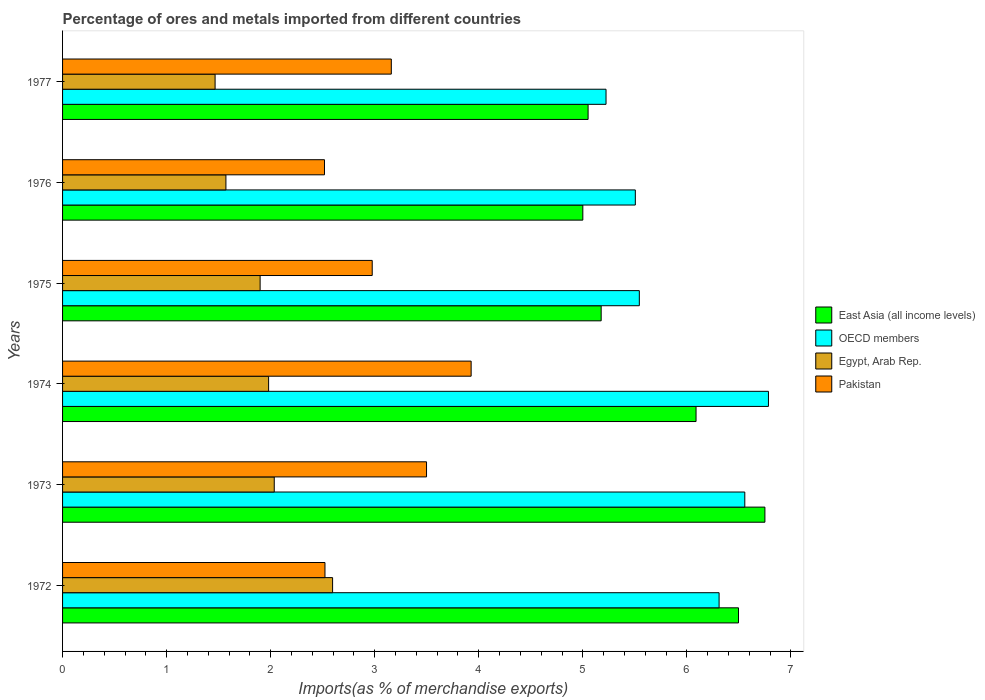What is the label of the 3rd group of bars from the top?
Give a very brief answer. 1975. In how many cases, is the number of bars for a given year not equal to the number of legend labels?
Ensure brevity in your answer.  0. What is the percentage of imports to different countries in East Asia (all income levels) in 1973?
Offer a terse response. 6.75. Across all years, what is the maximum percentage of imports to different countries in Pakistan?
Your answer should be compact. 3.93. Across all years, what is the minimum percentage of imports to different countries in OECD members?
Offer a terse response. 5.22. In which year was the percentage of imports to different countries in Pakistan maximum?
Provide a short and direct response. 1974. In which year was the percentage of imports to different countries in East Asia (all income levels) minimum?
Offer a very short reply. 1976. What is the total percentage of imports to different countries in OECD members in the graph?
Provide a succinct answer. 35.92. What is the difference between the percentage of imports to different countries in Pakistan in 1975 and that in 1976?
Your answer should be very brief. 0.46. What is the difference between the percentage of imports to different countries in Egypt, Arab Rep. in 1977 and the percentage of imports to different countries in East Asia (all income levels) in 1974?
Your response must be concise. -4.62. What is the average percentage of imports to different countries in East Asia (all income levels) per year?
Provide a short and direct response. 5.76. In the year 1976, what is the difference between the percentage of imports to different countries in Pakistan and percentage of imports to different countries in East Asia (all income levels)?
Ensure brevity in your answer.  -2.48. In how many years, is the percentage of imports to different countries in Pakistan greater than 2.6 %?
Make the answer very short. 4. What is the ratio of the percentage of imports to different countries in Pakistan in 1975 to that in 1976?
Give a very brief answer. 1.18. Is the difference between the percentage of imports to different countries in Pakistan in 1973 and 1976 greater than the difference between the percentage of imports to different countries in East Asia (all income levels) in 1973 and 1976?
Provide a succinct answer. No. What is the difference between the highest and the second highest percentage of imports to different countries in OECD members?
Keep it short and to the point. 0.23. What is the difference between the highest and the lowest percentage of imports to different countries in Egypt, Arab Rep.?
Keep it short and to the point. 1.13. In how many years, is the percentage of imports to different countries in OECD members greater than the average percentage of imports to different countries in OECD members taken over all years?
Your answer should be compact. 3. Is it the case that in every year, the sum of the percentage of imports to different countries in Pakistan and percentage of imports to different countries in OECD members is greater than the sum of percentage of imports to different countries in Egypt, Arab Rep. and percentage of imports to different countries in East Asia (all income levels)?
Offer a very short reply. No. What does the 2nd bar from the top in 1977 represents?
Keep it short and to the point. Egypt, Arab Rep. Is it the case that in every year, the sum of the percentage of imports to different countries in Egypt, Arab Rep. and percentage of imports to different countries in East Asia (all income levels) is greater than the percentage of imports to different countries in Pakistan?
Provide a succinct answer. Yes. How many bars are there?
Provide a short and direct response. 24. Are all the bars in the graph horizontal?
Keep it short and to the point. Yes. How many years are there in the graph?
Provide a short and direct response. 6. Does the graph contain any zero values?
Your answer should be very brief. No. What is the title of the graph?
Offer a terse response. Percentage of ores and metals imported from different countries. What is the label or title of the X-axis?
Give a very brief answer. Imports(as % of merchandise exports). What is the Imports(as % of merchandise exports) in East Asia (all income levels) in 1972?
Make the answer very short. 6.5. What is the Imports(as % of merchandise exports) in OECD members in 1972?
Offer a very short reply. 6.31. What is the Imports(as % of merchandise exports) in Egypt, Arab Rep. in 1972?
Provide a short and direct response. 2.59. What is the Imports(as % of merchandise exports) in Pakistan in 1972?
Ensure brevity in your answer.  2.52. What is the Imports(as % of merchandise exports) of East Asia (all income levels) in 1973?
Provide a succinct answer. 6.75. What is the Imports(as % of merchandise exports) in OECD members in 1973?
Your answer should be very brief. 6.56. What is the Imports(as % of merchandise exports) in Egypt, Arab Rep. in 1973?
Provide a succinct answer. 2.03. What is the Imports(as % of merchandise exports) in Pakistan in 1973?
Keep it short and to the point. 3.5. What is the Imports(as % of merchandise exports) of East Asia (all income levels) in 1974?
Your answer should be compact. 6.09. What is the Imports(as % of merchandise exports) in OECD members in 1974?
Your answer should be compact. 6.78. What is the Imports(as % of merchandise exports) in Egypt, Arab Rep. in 1974?
Offer a very short reply. 1.98. What is the Imports(as % of merchandise exports) in Pakistan in 1974?
Make the answer very short. 3.93. What is the Imports(as % of merchandise exports) in East Asia (all income levels) in 1975?
Provide a short and direct response. 5.18. What is the Imports(as % of merchandise exports) of OECD members in 1975?
Offer a very short reply. 5.54. What is the Imports(as % of merchandise exports) of Egypt, Arab Rep. in 1975?
Provide a short and direct response. 1.9. What is the Imports(as % of merchandise exports) of Pakistan in 1975?
Your answer should be compact. 2.98. What is the Imports(as % of merchandise exports) in East Asia (all income levels) in 1976?
Ensure brevity in your answer.  5. What is the Imports(as % of merchandise exports) in OECD members in 1976?
Provide a succinct answer. 5.5. What is the Imports(as % of merchandise exports) in Egypt, Arab Rep. in 1976?
Provide a succinct answer. 1.57. What is the Imports(as % of merchandise exports) in Pakistan in 1976?
Your answer should be compact. 2.52. What is the Imports(as % of merchandise exports) of East Asia (all income levels) in 1977?
Your response must be concise. 5.05. What is the Imports(as % of merchandise exports) in OECD members in 1977?
Provide a short and direct response. 5.22. What is the Imports(as % of merchandise exports) in Egypt, Arab Rep. in 1977?
Provide a short and direct response. 1.47. What is the Imports(as % of merchandise exports) in Pakistan in 1977?
Your answer should be compact. 3.16. Across all years, what is the maximum Imports(as % of merchandise exports) in East Asia (all income levels)?
Provide a short and direct response. 6.75. Across all years, what is the maximum Imports(as % of merchandise exports) in OECD members?
Offer a terse response. 6.78. Across all years, what is the maximum Imports(as % of merchandise exports) in Egypt, Arab Rep.?
Provide a succinct answer. 2.59. Across all years, what is the maximum Imports(as % of merchandise exports) of Pakistan?
Provide a short and direct response. 3.93. Across all years, what is the minimum Imports(as % of merchandise exports) of East Asia (all income levels)?
Provide a succinct answer. 5. Across all years, what is the minimum Imports(as % of merchandise exports) in OECD members?
Ensure brevity in your answer.  5.22. Across all years, what is the minimum Imports(as % of merchandise exports) in Egypt, Arab Rep.?
Make the answer very short. 1.47. Across all years, what is the minimum Imports(as % of merchandise exports) of Pakistan?
Your answer should be very brief. 2.52. What is the total Imports(as % of merchandise exports) in East Asia (all income levels) in the graph?
Your answer should be compact. 34.56. What is the total Imports(as % of merchandise exports) in OECD members in the graph?
Keep it short and to the point. 35.92. What is the total Imports(as % of merchandise exports) of Egypt, Arab Rep. in the graph?
Provide a short and direct response. 11.54. What is the total Imports(as % of merchandise exports) in Pakistan in the graph?
Give a very brief answer. 18.6. What is the difference between the Imports(as % of merchandise exports) of East Asia (all income levels) in 1972 and that in 1973?
Your answer should be compact. -0.25. What is the difference between the Imports(as % of merchandise exports) of OECD members in 1972 and that in 1973?
Offer a terse response. -0.25. What is the difference between the Imports(as % of merchandise exports) in Egypt, Arab Rep. in 1972 and that in 1973?
Your answer should be very brief. 0.56. What is the difference between the Imports(as % of merchandise exports) of Pakistan in 1972 and that in 1973?
Offer a terse response. -0.98. What is the difference between the Imports(as % of merchandise exports) in East Asia (all income levels) in 1972 and that in 1974?
Provide a short and direct response. 0.41. What is the difference between the Imports(as % of merchandise exports) of OECD members in 1972 and that in 1974?
Your response must be concise. -0.47. What is the difference between the Imports(as % of merchandise exports) in Egypt, Arab Rep. in 1972 and that in 1974?
Your answer should be very brief. 0.61. What is the difference between the Imports(as % of merchandise exports) of Pakistan in 1972 and that in 1974?
Your answer should be compact. -1.4. What is the difference between the Imports(as % of merchandise exports) of East Asia (all income levels) in 1972 and that in 1975?
Keep it short and to the point. 1.32. What is the difference between the Imports(as % of merchandise exports) in OECD members in 1972 and that in 1975?
Ensure brevity in your answer.  0.77. What is the difference between the Imports(as % of merchandise exports) of Egypt, Arab Rep. in 1972 and that in 1975?
Give a very brief answer. 0.7. What is the difference between the Imports(as % of merchandise exports) in Pakistan in 1972 and that in 1975?
Your answer should be compact. -0.45. What is the difference between the Imports(as % of merchandise exports) of East Asia (all income levels) in 1972 and that in 1976?
Your answer should be compact. 1.5. What is the difference between the Imports(as % of merchandise exports) of OECD members in 1972 and that in 1976?
Make the answer very short. 0.81. What is the difference between the Imports(as % of merchandise exports) of Egypt, Arab Rep. in 1972 and that in 1976?
Your response must be concise. 1.03. What is the difference between the Imports(as % of merchandise exports) of Pakistan in 1972 and that in 1976?
Ensure brevity in your answer.  0. What is the difference between the Imports(as % of merchandise exports) of East Asia (all income levels) in 1972 and that in 1977?
Give a very brief answer. 1.45. What is the difference between the Imports(as % of merchandise exports) of OECD members in 1972 and that in 1977?
Your response must be concise. 1.09. What is the difference between the Imports(as % of merchandise exports) of Egypt, Arab Rep. in 1972 and that in 1977?
Give a very brief answer. 1.13. What is the difference between the Imports(as % of merchandise exports) of Pakistan in 1972 and that in 1977?
Offer a terse response. -0.64. What is the difference between the Imports(as % of merchandise exports) in East Asia (all income levels) in 1973 and that in 1974?
Your answer should be compact. 0.66. What is the difference between the Imports(as % of merchandise exports) of OECD members in 1973 and that in 1974?
Offer a very short reply. -0.23. What is the difference between the Imports(as % of merchandise exports) in Egypt, Arab Rep. in 1973 and that in 1974?
Give a very brief answer. 0.05. What is the difference between the Imports(as % of merchandise exports) in Pakistan in 1973 and that in 1974?
Offer a very short reply. -0.43. What is the difference between the Imports(as % of merchandise exports) of East Asia (all income levels) in 1973 and that in 1975?
Offer a very short reply. 1.57. What is the difference between the Imports(as % of merchandise exports) in OECD members in 1973 and that in 1975?
Give a very brief answer. 1.01. What is the difference between the Imports(as % of merchandise exports) of Egypt, Arab Rep. in 1973 and that in 1975?
Provide a succinct answer. 0.14. What is the difference between the Imports(as % of merchandise exports) of Pakistan in 1973 and that in 1975?
Ensure brevity in your answer.  0.52. What is the difference between the Imports(as % of merchandise exports) of East Asia (all income levels) in 1973 and that in 1976?
Your answer should be very brief. 1.75. What is the difference between the Imports(as % of merchandise exports) of OECD members in 1973 and that in 1976?
Offer a very short reply. 1.05. What is the difference between the Imports(as % of merchandise exports) in Egypt, Arab Rep. in 1973 and that in 1976?
Your answer should be very brief. 0.46. What is the difference between the Imports(as % of merchandise exports) in Pakistan in 1973 and that in 1976?
Offer a terse response. 0.98. What is the difference between the Imports(as % of merchandise exports) in East Asia (all income levels) in 1973 and that in 1977?
Keep it short and to the point. 1.7. What is the difference between the Imports(as % of merchandise exports) of OECD members in 1973 and that in 1977?
Ensure brevity in your answer.  1.33. What is the difference between the Imports(as % of merchandise exports) in Egypt, Arab Rep. in 1973 and that in 1977?
Your response must be concise. 0.57. What is the difference between the Imports(as % of merchandise exports) of Pakistan in 1973 and that in 1977?
Offer a terse response. 0.34. What is the difference between the Imports(as % of merchandise exports) in East Asia (all income levels) in 1974 and that in 1975?
Keep it short and to the point. 0.91. What is the difference between the Imports(as % of merchandise exports) of OECD members in 1974 and that in 1975?
Ensure brevity in your answer.  1.24. What is the difference between the Imports(as % of merchandise exports) of Egypt, Arab Rep. in 1974 and that in 1975?
Make the answer very short. 0.08. What is the difference between the Imports(as % of merchandise exports) of Pakistan in 1974 and that in 1975?
Keep it short and to the point. 0.95. What is the difference between the Imports(as % of merchandise exports) of East Asia (all income levels) in 1974 and that in 1976?
Provide a short and direct response. 1.09. What is the difference between the Imports(as % of merchandise exports) in OECD members in 1974 and that in 1976?
Your response must be concise. 1.28. What is the difference between the Imports(as % of merchandise exports) of Egypt, Arab Rep. in 1974 and that in 1976?
Keep it short and to the point. 0.41. What is the difference between the Imports(as % of merchandise exports) in Pakistan in 1974 and that in 1976?
Your answer should be compact. 1.41. What is the difference between the Imports(as % of merchandise exports) of East Asia (all income levels) in 1974 and that in 1977?
Provide a succinct answer. 1.04. What is the difference between the Imports(as % of merchandise exports) of OECD members in 1974 and that in 1977?
Offer a terse response. 1.56. What is the difference between the Imports(as % of merchandise exports) of Egypt, Arab Rep. in 1974 and that in 1977?
Your answer should be compact. 0.51. What is the difference between the Imports(as % of merchandise exports) of Pakistan in 1974 and that in 1977?
Ensure brevity in your answer.  0.77. What is the difference between the Imports(as % of merchandise exports) in East Asia (all income levels) in 1975 and that in 1976?
Ensure brevity in your answer.  0.18. What is the difference between the Imports(as % of merchandise exports) in OECD members in 1975 and that in 1976?
Provide a short and direct response. 0.04. What is the difference between the Imports(as % of merchandise exports) in Egypt, Arab Rep. in 1975 and that in 1976?
Offer a terse response. 0.33. What is the difference between the Imports(as % of merchandise exports) in Pakistan in 1975 and that in 1976?
Your response must be concise. 0.46. What is the difference between the Imports(as % of merchandise exports) of East Asia (all income levels) in 1975 and that in 1977?
Keep it short and to the point. 0.13. What is the difference between the Imports(as % of merchandise exports) in OECD members in 1975 and that in 1977?
Make the answer very short. 0.32. What is the difference between the Imports(as % of merchandise exports) of Egypt, Arab Rep. in 1975 and that in 1977?
Your response must be concise. 0.43. What is the difference between the Imports(as % of merchandise exports) in Pakistan in 1975 and that in 1977?
Offer a very short reply. -0.18. What is the difference between the Imports(as % of merchandise exports) of East Asia (all income levels) in 1976 and that in 1977?
Ensure brevity in your answer.  -0.05. What is the difference between the Imports(as % of merchandise exports) of OECD members in 1976 and that in 1977?
Your answer should be compact. 0.28. What is the difference between the Imports(as % of merchandise exports) of Egypt, Arab Rep. in 1976 and that in 1977?
Your answer should be very brief. 0.1. What is the difference between the Imports(as % of merchandise exports) of Pakistan in 1976 and that in 1977?
Provide a succinct answer. -0.64. What is the difference between the Imports(as % of merchandise exports) in East Asia (all income levels) in 1972 and the Imports(as % of merchandise exports) in OECD members in 1973?
Ensure brevity in your answer.  -0.06. What is the difference between the Imports(as % of merchandise exports) in East Asia (all income levels) in 1972 and the Imports(as % of merchandise exports) in Egypt, Arab Rep. in 1973?
Your response must be concise. 4.46. What is the difference between the Imports(as % of merchandise exports) of East Asia (all income levels) in 1972 and the Imports(as % of merchandise exports) of Pakistan in 1973?
Your answer should be very brief. 3. What is the difference between the Imports(as % of merchandise exports) in OECD members in 1972 and the Imports(as % of merchandise exports) in Egypt, Arab Rep. in 1973?
Offer a terse response. 4.27. What is the difference between the Imports(as % of merchandise exports) in OECD members in 1972 and the Imports(as % of merchandise exports) in Pakistan in 1973?
Provide a succinct answer. 2.81. What is the difference between the Imports(as % of merchandise exports) in Egypt, Arab Rep. in 1972 and the Imports(as % of merchandise exports) in Pakistan in 1973?
Your answer should be compact. -0.9. What is the difference between the Imports(as % of merchandise exports) of East Asia (all income levels) in 1972 and the Imports(as % of merchandise exports) of OECD members in 1974?
Provide a short and direct response. -0.29. What is the difference between the Imports(as % of merchandise exports) of East Asia (all income levels) in 1972 and the Imports(as % of merchandise exports) of Egypt, Arab Rep. in 1974?
Make the answer very short. 4.52. What is the difference between the Imports(as % of merchandise exports) in East Asia (all income levels) in 1972 and the Imports(as % of merchandise exports) in Pakistan in 1974?
Make the answer very short. 2.57. What is the difference between the Imports(as % of merchandise exports) in OECD members in 1972 and the Imports(as % of merchandise exports) in Egypt, Arab Rep. in 1974?
Provide a succinct answer. 4.33. What is the difference between the Imports(as % of merchandise exports) of OECD members in 1972 and the Imports(as % of merchandise exports) of Pakistan in 1974?
Your answer should be compact. 2.38. What is the difference between the Imports(as % of merchandise exports) in Egypt, Arab Rep. in 1972 and the Imports(as % of merchandise exports) in Pakistan in 1974?
Make the answer very short. -1.33. What is the difference between the Imports(as % of merchandise exports) of East Asia (all income levels) in 1972 and the Imports(as % of merchandise exports) of OECD members in 1975?
Give a very brief answer. 0.95. What is the difference between the Imports(as % of merchandise exports) in East Asia (all income levels) in 1972 and the Imports(as % of merchandise exports) in Egypt, Arab Rep. in 1975?
Provide a succinct answer. 4.6. What is the difference between the Imports(as % of merchandise exports) in East Asia (all income levels) in 1972 and the Imports(as % of merchandise exports) in Pakistan in 1975?
Your answer should be compact. 3.52. What is the difference between the Imports(as % of merchandise exports) of OECD members in 1972 and the Imports(as % of merchandise exports) of Egypt, Arab Rep. in 1975?
Offer a terse response. 4.41. What is the difference between the Imports(as % of merchandise exports) of OECD members in 1972 and the Imports(as % of merchandise exports) of Pakistan in 1975?
Give a very brief answer. 3.33. What is the difference between the Imports(as % of merchandise exports) of Egypt, Arab Rep. in 1972 and the Imports(as % of merchandise exports) of Pakistan in 1975?
Provide a short and direct response. -0.38. What is the difference between the Imports(as % of merchandise exports) in East Asia (all income levels) in 1972 and the Imports(as % of merchandise exports) in Egypt, Arab Rep. in 1976?
Ensure brevity in your answer.  4.93. What is the difference between the Imports(as % of merchandise exports) in East Asia (all income levels) in 1972 and the Imports(as % of merchandise exports) in Pakistan in 1976?
Make the answer very short. 3.98. What is the difference between the Imports(as % of merchandise exports) in OECD members in 1972 and the Imports(as % of merchandise exports) in Egypt, Arab Rep. in 1976?
Offer a very short reply. 4.74. What is the difference between the Imports(as % of merchandise exports) of OECD members in 1972 and the Imports(as % of merchandise exports) of Pakistan in 1976?
Ensure brevity in your answer.  3.79. What is the difference between the Imports(as % of merchandise exports) in Egypt, Arab Rep. in 1972 and the Imports(as % of merchandise exports) in Pakistan in 1976?
Your response must be concise. 0.08. What is the difference between the Imports(as % of merchandise exports) in East Asia (all income levels) in 1972 and the Imports(as % of merchandise exports) in OECD members in 1977?
Offer a terse response. 1.27. What is the difference between the Imports(as % of merchandise exports) in East Asia (all income levels) in 1972 and the Imports(as % of merchandise exports) in Egypt, Arab Rep. in 1977?
Give a very brief answer. 5.03. What is the difference between the Imports(as % of merchandise exports) in East Asia (all income levels) in 1972 and the Imports(as % of merchandise exports) in Pakistan in 1977?
Your response must be concise. 3.34. What is the difference between the Imports(as % of merchandise exports) in OECD members in 1972 and the Imports(as % of merchandise exports) in Egypt, Arab Rep. in 1977?
Give a very brief answer. 4.84. What is the difference between the Imports(as % of merchandise exports) in OECD members in 1972 and the Imports(as % of merchandise exports) in Pakistan in 1977?
Give a very brief answer. 3.15. What is the difference between the Imports(as % of merchandise exports) of Egypt, Arab Rep. in 1972 and the Imports(as % of merchandise exports) of Pakistan in 1977?
Give a very brief answer. -0.56. What is the difference between the Imports(as % of merchandise exports) in East Asia (all income levels) in 1973 and the Imports(as % of merchandise exports) in OECD members in 1974?
Offer a terse response. -0.03. What is the difference between the Imports(as % of merchandise exports) of East Asia (all income levels) in 1973 and the Imports(as % of merchandise exports) of Egypt, Arab Rep. in 1974?
Offer a terse response. 4.77. What is the difference between the Imports(as % of merchandise exports) of East Asia (all income levels) in 1973 and the Imports(as % of merchandise exports) of Pakistan in 1974?
Offer a very short reply. 2.82. What is the difference between the Imports(as % of merchandise exports) of OECD members in 1973 and the Imports(as % of merchandise exports) of Egypt, Arab Rep. in 1974?
Ensure brevity in your answer.  4.58. What is the difference between the Imports(as % of merchandise exports) in OECD members in 1973 and the Imports(as % of merchandise exports) in Pakistan in 1974?
Give a very brief answer. 2.63. What is the difference between the Imports(as % of merchandise exports) in Egypt, Arab Rep. in 1973 and the Imports(as % of merchandise exports) in Pakistan in 1974?
Your answer should be very brief. -1.89. What is the difference between the Imports(as % of merchandise exports) of East Asia (all income levels) in 1973 and the Imports(as % of merchandise exports) of OECD members in 1975?
Give a very brief answer. 1.21. What is the difference between the Imports(as % of merchandise exports) of East Asia (all income levels) in 1973 and the Imports(as % of merchandise exports) of Egypt, Arab Rep. in 1975?
Your answer should be compact. 4.85. What is the difference between the Imports(as % of merchandise exports) in East Asia (all income levels) in 1973 and the Imports(as % of merchandise exports) in Pakistan in 1975?
Provide a succinct answer. 3.77. What is the difference between the Imports(as % of merchandise exports) in OECD members in 1973 and the Imports(as % of merchandise exports) in Egypt, Arab Rep. in 1975?
Keep it short and to the point. 4.66. What is the difference between the Imports(as % of merchandise exports) of OECD members in 1973 and the Imports(as % of merchandise exports) of Pakistan in 1975?
Keep it short and to the point. 3.58. What is the difference between the Imports(as % of merchandise exports) of Egypt, Arab Rep. in 1973 and the Imports(as % of merchandise exports) of Pakistan in 1975?
Your answer should be very brief. -0.94. What is the difference between the Imports(as % of merchandise exports) of East Asia (all income levels) in 1973 and the Imports(as % of merchandise exports) of OECD members in 1976?
Your response must be concise. 1.25. What is the difference between the Imports(as % of merchandise exports) in East Asia (all income levels) in 1973 and the Imports(as % of merchandise exports) in Egypt, Arab Rep. in 1976?
Give a very brief answer. 5.18. What is the difference between the Imports(as % of merchandise exports) of East Asia (all income levels) in 1973 and the Imports(as % of merchandise exports) of Pakistan in 1976?
Make the answer very short. 4.23. What is the difference between the Imports(as % of merchandise exports) in OECD members in 1973 and the Imports(as % of merchandise exports) in Egypt, Arab Rep. in 1976?
Make the answer very short. 4.99. What is the difference between the Imports(as % of merchandise exports) of OECD members in 1973 and the Imports(as % of merchandise exports) of Pakistan in 1976?
Provide a succinct answer. 4.04. What is the difference between the Imports(as % of merchandise exports) of Egypt, Arab Rep. in 1973 and the Imports(as % of merchandise exports) of Pakistan in 1976?
Ensure brevity in your answer.  -0.48. What is the difference between the Imports(as % of merchandise exports) in East Asia (all income levels) in 1973 and the Imports(as % of merchandise exports) in OECD members in 1977?
Make the answer very short. 1.53. What is the difference between the Imports(as % of merchandise exports) in East Asia (all income levels) in 1973 and the Imports(as % of merchandise exports) in Egypt, Arab Rep. in 1977?
Your answer should be compact. 5.28. What is the difference between the Imports(as % of merchandise exports) of East Asia (all income levels) in 1973 and the Imports(as % of merchandise exports) of Pakistan in 1977?
Your response must be concise. 3.59. What is the difference between the Imports(as % of merchandise exports) in OECD members in 1973 and the Imports(as % of merchandise exports) in Egypt, Arab Rep. in 1977?
Provide a short and direct response. 5.09. What is the difference between the Imports(as % of merchandise exports) in OECD members in 1973 and the Imports(as % of merchandise exports) in Pakistan in 1977?
Provide a succinct answer. 3.4. What is the difference between the Imports(as % of merchandise exports) in Egypt, Arab Rep. in 1973 and the Imports(as % of merchandise exports) in Pakistan in 1977?
Make the answer very short. -1.12. What is the difference between the Imports(as % of merchandise exports) of East Asia (all income levels) in 1974 and the Imports(as % of merchandise exports) of OECD members in 1975?
Your answer should be very brief. 0.55. What is the difference between the Imports(as % of merchandise exports) in East Asia (all income levels) in 1974 and the Imports(as % of merchandise exports) in Egypt, Arab Rep. in 1975?
Give a very brief answer. 4.19. What is the difference between the Imports(as % of merchandise exports) in East Asia (all income levels) in 1974 and the Imports(as % of merchandise exports) in Pakistan in 1975?
Provide a succinct answer. 3.11. What is the difference between the Imports(as % of merchandise exports) of OECD members in 1974 and the Imports(as % of merchandise exports) of Egypt, Arab Rep. in 1975?
Your response must be concise. 4.88. What is the difference between the Imports(as % of merchandise exports) of OECD members in 1974 and the Imports(as % of merchandise exports) of Pakistan in 1975?
Ensure brevity in your answer.  3.81. What is the difference between the Imports(as % of merchandise exports) in Egypt, Arab Rep. in 1974 and the Imports(as % of merchandise exports) in Pakistan in 1975?
Provide a short and direct response. -1. What is the difference between the Imports(as % of merchandise exports) of East Asia (all income levels) in 1974 and the Imports(as % of merchandise exports) of OECD members in 1976?
Keep it short and to the point. 0.58. What is the difference between the Imports(as % of merchandise exports) of East Asia (all income levels) in 1974 and the Imports(as % of merchandise exports) of Egypt, Arab Rep. in 1976?
Your answer should be very brief. 4.52. What is the difference between the Imports(as % of merchandise exports) in East Asia (all income levels) in 1974 and the Imports(as % of merchandise exports) in Pakistan in 1976?
Keep it short and to the point. 3.57. What is the difference between the Imports(as % of merchandise exports) in OECD members in 1974 and the Imports(as % of merchandise exports) in Egypt, Arab Rep. in 1976?
Make the answer very short. 5.21. What is the difference between the Imports(as % of merchandise exports) in OECD members in 1974 and the Imports(as % of merchandise exports) in Pakistan in 1976?
Keep it short and to the point. 4.27. What is the difference between the Imports(as % of merchandise exports) of Egypt, Arab Rep. in 1974 and the Imports(as % of merchandise exports) of Pakistan in 1976?
Make the answer very short. -0.54. What is the difference between the Imports(as % of merchandise exports) in East Asia (all income levels) in 1974 and the Imports(as % of merchandise exports) in OECD members in 1977?
Make the answer very short. 0.86. What is the difference between the Imports(as % of merchandise exports) in East Asia (all income levels) in 1974 and the Imports(as % of merchandise exports) in Egypt, Arab Rep. in 1977?
Give a very brief answer. 4.62. What is the difference between the Imports(as % of merchandise exports) of East Asia (all income levels) in 1974 and the Imports(as % of merchandise exports) of Pakistan in 1977?
Your answer should be very brief. 2.93. What is the difference between the Imports(as % of merchandise exports) of OECD members in 1974 and the Imports(as % of merchandise exports) of Egypt, Arab Rep. in 1977?
Provide a short and direct response. 5.32. What is the difference between the Imports(as % of merchandise exports) in OECD members in 1974 and the Imports(as % of merchandise exports) in Pakistan in 1977?
Your answer should be compact. 3.62. What is the difference between the Imports(as % of merchandise exports) in Egypt, Arab Rep. in 1974 and the Imports(as % of merchandise exports) in Pakistan in 1977?
Give a very brief answer. -1.18. What is the difference between the Imports(as % of merchandise exports) in East Asia (all income levels) in 1975 and the Imports(as % of merchandise exports) in OECD members in 1976?
Offer a very short reply. -0.33. What is the difference between the Imports(as % of merchandise exports) in East Asia (all income levels) in 1975 and the Imports(as % of merchandise exports) in Egypt, Arab Rep. in 1976?
Make the answer very short. 3.61. What is the difference between the Imports(as % of merchandise exports) of East Asia (all income levels) in 1975 and the Imports(as % of merchandise exports) of Pakistan in 1976?
Your response must be concise. 2.66. What is the difference between the Imports(as % of merchandise exports) of OECD members in 1975 and the Imports(as % of merchandise exports) of Egypt, Arab Rep. in 1976?
Your response must be concise. 3.97. What is the difference between the Imports(as % of merchandise exports) in OECD members in 1975 and the Imports(as % of merchandise exports) in Pakistan in 1976?
Make the answer very short. 3.03. What is the difference between the Imports(as % of merchandise exports) of Egypt, Arab Rep. in 1975 and the Imports(as % of merchandise exports) of Pakistan in 1976?
Offer a terse response. -0.62. What is the difference between the Imports(as % of merchandise exports) in East Asia (all income levels) in 1975 and the Imports(as % of merchandise exports) in OECD members in 1977?
Give a very brief answer. -0.05. What is the difference between the Imports(as % of merchandise exports) of East Asia (all income levels) in 1975 and the Imports(as % of merchandise exports) of Egypt, Arab Rep. in 1977?
Ensure brevity in your answer.  3.71. What is the difference between the Imports(as % of merchandise exports) of East Asia (all income levels) in 1975 and the Imports(as % of merchandise exports) of Pakistan in 1977?
Offer a very short reply. 2.02. What is the difference between the Imports(as % of merchandise exports) of OECD members in 1975 and the Imports(as % of merchandise exports) of Egypt, Arab Rep. in 1977?
Offer a very short reply. 4.08. What is the difference between the Imports(as % of merchandise exports) in OECD members in 1975 and the Imports(as % of merchandise exports) in Pakistan in 1977?
Provide a short and direct response. 2.38. What is the difference between the Imports(as % of merchandise exports) in Egypt, Arab Rep. in 1975 and the Imports(as % of merchandise exports) in Pakistan in 1977?
Ensure brevity in your answer.  -1.26. What is the difference between the Imports(as % of merchandise exports) of East Asia (all income levels) in 1976 and the Imports(as % of merchandise exports) of OECD members in 1977?
Your answer should be compact. -0.22. What is the difference between the Imports(as % of merchandise exports) of East Asia (all income levels) in 1976 and the Imports(as % of merchandise exports) of Egypt, Arab Rep. in 1977?
Keep it short and to the point. 3.53. What is the difference between the Imports(as % of merchandise exports) in East Asia (all income levels) in 1976 and the Imports(as % of merchandise exports) in Pakistan in 1977?
Provide a short and direct response. 1.84. What is the difference between the Imports(as % of merchandise exports) in OECD members in 1976 and the Imports(as % of merchandise exports) in Egypt, Arab Rep. in 1977?
Keep it short and to the point. 4.04. What is the difference between the Imports(as % of merchandise exports) in OECD members in 1976 and the Imports(as % of merchandise exports) in Pakistan in 1977?
Provide a succinct answer. 2.35. What is the difference between the Imports(as % of merchandise exports) of Egypt, Arab Rep. in 1976 and the Imports(as % of merchandise exports) of Pakistan in 1977?
Keep it short and to the point. -1.59. What is the average Imports(as % of merchandise exports) in East Asia (all income levels) per year?
Your response must be concise. 5.76. What is the average Imports(as % of merchandise exports) in OECD members per year?
Your answer should be compact. 5.99. What is the average Imports(as % of merchandise exports) in Egypt, Arab Rep. per year?
Your response must be concise. 1.92. What is the average Imports(as % of merchandise exports) in Pakistan per year?
Your answer should be compact. 3.1. In the year 1972, what is the difference between the Imports(as % of merchandise exports) of East Asia (all income levels) and Imports(as % of merchandise exports) of OECD members?
Provide a succinct answer. 0.19. In the year 1972, what is the difference between the Imports(as % of merchandise exports) of East Asia (all income levels) and Imports(as % of merchandise exports) of Egypt, Arab Rep.?
Ensure brevity in your answer.  3.9. In the year 1972, what is the difference between the Imports(as % of merchandise exports) of East Asia (all income levels) and Imports(as % of merchandise exports) of Pakistan?
Offer a very short reply. 3.97. In the year 1972, what is the difference between the Imports(as % of merchandise exports) in OECD members and Imports(as % of merchandise exports) in Egypt, Arab Rep.?
Make the answer very short. 3.71. In the year 1972, what is the difference between the Imports(as % of merchandise exports) in OECD members and Imports(as % of merchandise exports) in Pakistan?
Your answer should be compact. 3.79. In the year 1972, what is the difference between the Imports(as % of merchandise exports) in Egypt, Arab Rep. and Imports(as % of merchandise exports) in Pakistan?
Give a very brief answer. 0.07. In the year 1973, what is the difference between the Imports(as % of merchandise exports) in East Asia (all income levels) and Imports(as % of merchandise exports) in OECD members?
Offer a terse response. 0.19. In the year 1973, what is the difference between the Imports(as % of merchandise exports) of East Asia (all income levels) and Imports(as % of merchandise exports) of Egypt, Arab Rep.?
Give a very brief answer. 4.72. In the year 1973, what is the difference between the Imports(as % of merchandise exports) of East Asia (all income levels) and Imports(as % of merchandise exports) of Pakistan?
Offer a very short reply. 3.25. In the year 1973, what is the difference between the Imports(as % of merchandise exports) of OECD members and Imports(as % of merchandise exports) of Egypt, Arab Rep.?
Ensure brevity in your answer.  4.52. In the year 1973, what is the difference between the Imports(as % of merchandise exports) in OECD members and Imports(as % of merchandise exports) in Pakistan?
Keep it short and to the point. 3.06. In the year 1973, what is the difference between the Imports(as % of merchandise exports) in Egypt, Arab Rep. and Imports(as % of merchandise exports) in Pakistan?
Provide a short and direct response. -1.46. In the year 1974, what is the difference between the Imports(as % of merchandise exports) of East Asia (all income levels) and Imports(as % of merchandise exports) of OECD members?
Provide a succinct answer. -0.7. In the year 1974, what is the difference between the Imports(as % of merchandise exports) in East Asia (all income levels) and Imports(as % of merchandise exports) in Egypt, Arab Rep.?
Keep it short and to the point. 4.11. In the year 1974, what is the difference between the Imports(as % of merchandise exports) in East Asia (all income levels) and Imports(as % of merchandise exports) in Pakistan?
Provide a short and direct response. 2.16. In the year 1974, what is the difference between the Imports(as % of merchandise exports) in OECD members and Imports(as % of merchandise exports) in Egypt, Arab Rep.?
Offer a terse response. 4.8. In the year 1974, what is the difference between the Imports(as % of merchandise exports) in OECD members and Imports(as % of merchandise exports) in Pakistan?
Make the answer very short. 2.86. In the year 1974, what is the difference between the Imports(as % of merchandise exports) in Egypt, Arab Rep. and Imports(as % of merchandise exports) in Pakistan?
Your response must be concise. -1.95. In the year 1975, what is the difference between the Imports(as % of merchandise exports) in East Asia (all income levels) and Imports(as % of merchandise exports) in OECD members?
Your answer should be very brief. -0.37. In the year 1975, what is the difference between the Imports(as % of merchandise exports) in East Asia (all income levels) and Imports(as % of merchandise exports) in Egypt, Arab Rep.?
Give a very brief answer. 3.28. In the year 1975, what is the difference between the Imports(as % of merchandise exports) of East Asia (all income levels) and Imports(as % of merchandise exports) of Pakistan?
Give a very brief answer. 2.2. In the year 1975, what is the difference between the Imports(as % of merchandise exports) in OECD members and Imports(as % of merchandise exports) in Egypt, Arab Rep.?
Ensure brevity in your answer.  3.64. In the year 1975, what is the difference between the Imports(as % of merchandise exports) of OECD members and Imports(as % of merchandise exports) of Pakistan?
Your answer should be very brief. 2.57. In the year 1975, what is the difference between the Imports(as % of merchandise exports) of Egypt, Arab Rep. and Imports(as % of merchandise exports) of Pakistan?
Provide a short and direct response. -1.08. In the year 1976, what is the difference between the Imports(as % of merchandise exports) in East Asia (all income levels) and Imports(as % of merchandise exports) in OECD members?
Offer a terse response. -0.5. In the year 1976, what is the difference between the Imports(as % of merchandise exports) in East Asia (all income levels) and Imports(as % of merchandise exports) in Egypt, Arab Rep.?
Your response must be concise. 3.43. In the year 1976, what is the difference between the Imports(as % of merchandise exports) in East Asia (all income levels) and Imports(as % of merchandise exports) in Pakistan?
Provide a short and direct response. 2.48. In the year 1976, what is the difference between the Imports(as % of merchandise exports) of OECD members and Imports(as % of merchandise exports) of Egypt, Arab Rep.?
Your response must be concise. 3.93. In the year 1976, what is the difference between the Imports(as % of merchandise exports) of OECD members and Imports(as % of merchandise exports) of Pakistan?
Keep it short and to the point. 2.99. In the year 1976, what is the difference between the Imports(as % of merchandise exports) of Egypt, Arab Rep. and Imports(as % of merchandise exports) of Pakistan?
Your response must be concise. -0.95. In the year 1977, what is the difference between the Imports(as % of merchandise exports) in East Asia (all income levels) and Imports(as % of merchandise exports) in OECD members?
Your answer should be very brief. -0.17. In the year 1977, what is the difference between the Imports(as % of merchandise exports) in East Asia (all income levels) and Imports(as % of merchandise exports) in Egypt, Arab Rep.?
Your response must be concise. 3.58. In the year 1977, what is the difference between the Imports(as % of merchandise exports) of East Asia (all income levels) and Imports(as % of merchandise exports) of Pakistan?
Ensure brevity in your answer.  1.89. In the year 1977, what is the difference between the Imports(as % of merchandise exports) in OECD members and Imports(as % of merchandise exports) in Egypt, Arab Rep.?
Offer a very short reply. 3.76. In the year 1977, what is the difference between the Imports(as % of merchandise exports) in OECD members and Imports(as % of merchandise exports) in Pakistan?
Offer a terse response. 2.06. In the year 1977, what is the difference between the Imports(as % of merchandise exports) in Egypt, Arab Rep. and Imports(as % of merchandise exports) in Pakistan?
Offer a very short reply. -1.69. What is the ratio of the Imports(as % of merchandise exports) in East Asia (all income levels) in 1972 to that in 1973?
Offer a very short reply. 0.96. What is the ratio of the Imports(as % of merchandise exports) of OECD members in 1972 to that in 1973?
Keep it short and to the point. 0.96. What is the ratio of the Imports(as % of merchandise exports) in Egypt, Arab Rep. in 1972 to that in 1973?
Provide a short and direct response. 1.28. What is the ratio of the Imports(as % of merchandise exports) in Pakistan in 1972 to that in 1973?
Make the answer very short. 0.72. What is the ratio of the Imports(as % of merchandise exports) in East Asia (all income levels) in 1972 to that in 1974?
Give a very brief answer. 1.07. What is the ratio of the Imports(as % of merchandise exports) of OECD members in 1972 to that in 1974?
Provide a succinct answer. 0.93. What is the ratio of the Imports(as % of merchandise exports) of Egypt, Arab Rep. in 1972 to that in 1974?
Your answer should be very brief. 1.31. What is the ratio of the Imports(as % of merchandise exports) in Pakistan in 1972 to that in 1974?
Give a very brief answer. 0.64. What is the ratio of the Imports(as % of merchandise exports) in East Asia (all income levels) in 1972 to that in 1975?
Your response must be concise. 1.25. What is the ratio of the Imports(as % of merchandise exports) in OECD members in 1972 to that in 1975?
Provide a short and direct response. 1.14. What is the ratio of the Imports(as % of merchandise exports) in Egypt, Arab Rep. in 1972 to that in 1975?
Ensure brevity in your answer.  1.37. What is the ratio of the Imports(as % of merchandise exports) of Pakistan in 1972 to that in 1975?
Your response must be concise. 0.85. What is the ratio of the Imports(as % of merchandise exports) in East Asia (all income levels) in 1972 to that in 1976?
Offer a terse response. 1.3. What is the ratio of the Imports(as % of merchandise exports) in OECD members in 1972 to that in 1976?
Keep it short and to the point. 1.15. What is the ratio of the Imports(as % of merchandise exports) of Egypt, Arab Rep. in 1972 to that in 1976?
Your answer should be very brief. 1.65. What is the ratio of the Imports(as % of merchandise exports) in East Asia (all income levels) in 1972 to that in 1977?
Give a very brief answer. 1.29. What is the ratio of the Imports(as % of merchandise exports) in OECD members in 1972 to that in 1977?
Give a very brief answer. 1.21. What is the ratio of the Imports(as % of merchandise exports) in Egypt, Arab Rep. in 1972 to that in 1977?
Your answer should be very brief. 1.77. What is the ratio of the Imports(as % of merchandise exports) of Pakistan in 1972 to that in 1977?
Ensure brevity in your answer.  0.8. What is the ratio of the Imports(as % of merchandise exports) of East Asia (all income levels) in 1973 to that in 1974?
Make the answer very short. 1.11. What is the ratio of the Imports(as % of merchandise exports) of OECD members in 1973 to that in 1974?
Offer a very short reply. 0.97. What is the ratio of the Imports(as % of merchandise exports) of Egypt, Arab Rep. in 1973 to that in 1974?
Make the answer very short. 1.03. What is the ratio of the Imports(as % of merchandise exports) of Pakistan in 1973 to that in 1974?
Offer a terse response. 0.89. What is the ratio of the Imports(as % of merchandise exports) in East Asia (all income levels) in 1973 to that in 1975?
Your answer should be compact. 1.3. What is the ratio of the Imports(as % of merchandise exports) of OECD members in 1973 to that in 1975?
Offer a very short reply. 1.18. What is the ratio of the Imports(as % of merchandise exports) of Egypt, Arab Rep. in 1973 to that in 1975?
Keep it short and to the point. 1.07. What is the ratio of the Imports(as % of merchandise exports) in Pakistan in 1973 to that in 1975?
Provide a short and direct response. 1.18. What is the ratio of the Imports(as % of merchandise exports) in East Asia (all income levels) in 1973 to that in 1976?
Your response must be concise. 1.35. What is the ratio of the Imports(as % of merchandise exports) in OECD members in 1973 to that in 1976?
Make the answer very short. 1.19. What is the ratio of the Imports(as % of merchandise exports) in Egypt, Arab Rep. in 1973 to that in 1976?
Your answer should be compact. 1.3. What is the ratio of the Imports(as % of merchandise exports) in Pakistan in 1973 to that in 1976?
Give a very brief answer. 1.39. What is the ratio of the Imports(as % of merchandise exports) of East Asia (all income levels) in 1973 to that in 1977?
Give a very brief answer. 1.34. What is the ratio of the Imports(as % of merchandise exports) of OECD members in 1973 to that in 1977?
Offer a terse response. 1.26. What is the ratio of the Imports(as % of merchandise exports) of Egypt, Arab Rep. in 1973 to that in 1977?
Keep it short and to the point. 1.39. What is the ratio of the Imports(as % of merchandise exports) of Pakistan in 1973 to that in 1977?
Ensure brevity in your answer.  1.11. What is the ratio of the Imports(as % of merchandise exports) in East Asia (all income levels) in 1974 to that in 1975?
Keep it short and to the point. 1.18. What is the ratio of the Imports(as % of merchandise exports) of OECD members in 1974 to that in 1975?
Offer a very short reply. 1.22. What is the ratio of the Imports(as % of merchandise exports) of Egypt, Arab Rep. in 1974 to that in 1975?
Your answer should be compact. 1.04. What is the ratio of the Imports(as % of merchandise exports) of Pakistan in 1974 to that in 1975?
Offer a very short reply. 1.32. What is the ratio of the Imports(as % of merchandise exports) of East Asia (all income levels) in 1974 to that in 1976?
Your answer should be very brief. 1.22. What is the ratio of the Imports(as % of merchandise exports) of OECD members in 1974 to that in 1976?
Make the answer very short. 1.23. What is the ratio of the Imports(as % of merchandise exports) in Egypt, Arab Rep. in 1974 to that in 1976?
Offer a terse response. 1.26. What is the ratio of the Imports(as % of merchandise exports) of Pakistan in 1974 to that in 1976?
Ensure brevity in your answer.  1.56. What is the ratio of the Imports(as % of merchandise exports) in East Asia (all income levels) in 1974 to that in 1977?
Provide a succinct answer. 1.21. What is the ratio of the Imports(as % of merchandise exports) of OECD members in 1974 to that in 1977?
Give a very brief answer. 1.3. What is the ratio of the Imports(as % of merchandise exports) in Egypt, Arab Rep. in 1974 to that in 1977?
Give a very brief answer. 1.35. What is the ratio of the Imports(as % of merchandise exports) in Pakistan in 1974 to that in 1977?
Provide a succinct answer. 1.24. What is the ratio of the Imports(as % of merchandise exports) in East Asia (all income levels) in 1975 to that in 1976?
Ensure brevity in your answer.  1.04. What is the ratio of the Imports(as % of merchandise exports) of OECD members in 1975 to that in 1976?
Offer a very short reply. 1.01. What is the ratio of the Imports(as % of merchandise exports) of Egypt, Arab Rep. in 1975 to that in 1976?
Offer a very short reply. 1.21. What is the ratio of the Imports(as % of merchandise exports) of Pakistan in 1975 to that in 1976?
Your answer should be very brief. 1.18. What is the ratio of the Imports(as % of merchandise exports) in East Asia (all income levels) in 1975 to that in 1977?
Your answer should be compact. 1.02. What is the ratio of the Imports(as % of merchandise exports) of OECD members in 1975 to that in 1977?
Offer a very short reply. 1.06. What is the ratio of the Imports(as % of merchandise exports) in Egypt, Arab Rep. in 1975 to that in 1977?
Provide a short and direct response. 1.3. What is the ratio of the Imports(as % of merchandise exports) of Pakistan in 1975 to that in 1977?
Your answer should be compact. 0.94. What is the ratio of the Imports(as % of merchandise exports) of East Asia (all income levels) in 1976 to that in 1977?
Offer a very short reply. 0.99. What is the ratio of the Imports(as % of merchandise exports) in OECD members in 1976 to that in 1977?
Give a very brief answer. 1.05. What is the ratio of the Imports(as % of merchandise exports) of Egypt, Arab Rep. in 1976 to that in 1977?
Offer a very short reply. 1.07. What is the ratio of the Imports(as % of merchandise exports) of Pakistan in 1976 to that in 1977?
Offer a terse response. 0.8. What is the difference between the highest and the second highest Imports(as % of merchandise exports) in East Asia (all income levels)?
Your answer should be very brief. 0.25. What is the difference between the highest and the second highest Imports(as % of merchandise exports) in OECD members?
Provide a succinct answer. 0.23. What is the difference between the highest and the second highest Imports(as % of merchandise exports) in Egypt, Arab Rep.?
Ensure brevity in your answer.  0.56. What is the difference between the highest and the second highest Imports(as % of merchandise exports) in Pakistan?
Your response must be concise. 0.43. What is the difference between the highest and the lowest Imports(as % of merchandise exports) in East Asia (all income levels)?
Provide a short and direct response. 1.75. What is the difference between the highest and the lowest Imports(as % of merchandise exports) in OECD members?
Make the answer very short. 1.56. What is the difference between the highest and the lowest Imports(as % of merchandise exports) of Egypt, Arab Rep.?
Ensure brevity in your answer.  1.13. What is the difference between the highest and the lowest Imports(as % of merchandise exports) of Pakistan?
Your answer should be very brief. 1.41. 